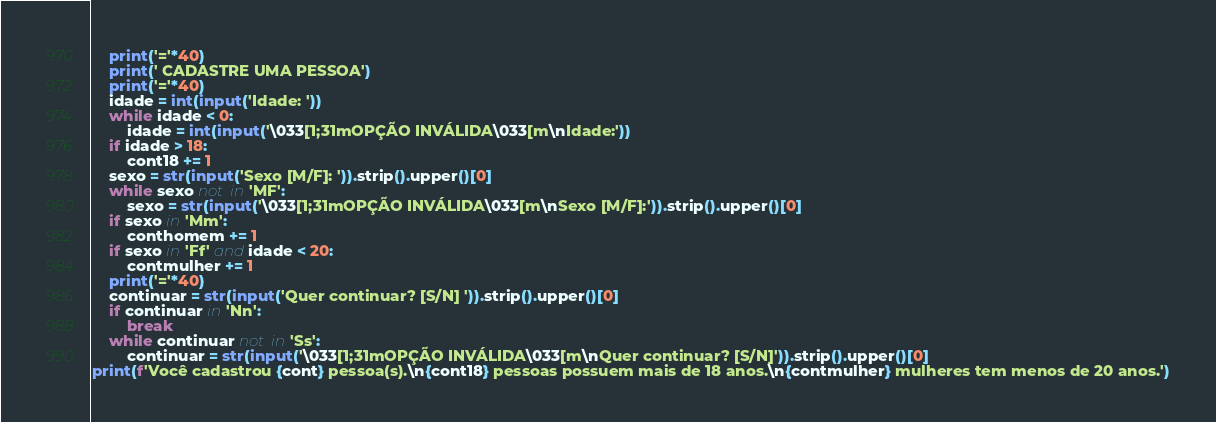Convert code to text. <code><loc_0><loc_0><loc_500><loc_500><_Python_>    print('='*40)
    print(' CADASTRE UMA PESSOA')
    print('='*40)
    idade = int(input('Idade: '))
    while idade < 0:
        idade = int(input('\033[1;31mOPÇÃO INVÁLIDA\033[m\nIdade:'))
    if idade > 18:
        cont18 += 1
    sexo = str(input('Sexo [M/F]: ')).strip().upper()[0]
    while sexo not in 'MF':
        sexo = str(input('\033[1;31mOPÇÃO INVÁLIDA\033[m\nSexo [M/F]:')).strip().upper()[0]
    if sexo in 'Mm':
        conthomem += 1
    if sexo in 'Ff' and idade < 20:
        contmulher += 1
    print('='*40)
    continuar = str(input('Quer continuar? [S/N] ')).strip().upper()[0]
    if continuar in 'Nn':
        break
    while continuar not in 'Ss':
        continuar = str(input('\033[1;31mOPÇÃO INVÁLIDA\033[m\nQuer continuar? [S/N]')).strip().upper()[0]
print(f'Você cadastrou {cont} pessoa(s).\n{cont18} pessoas possuem mais de 18 anos.\n{contmulher} mulheres tem menos de 20 anos.')</code> 